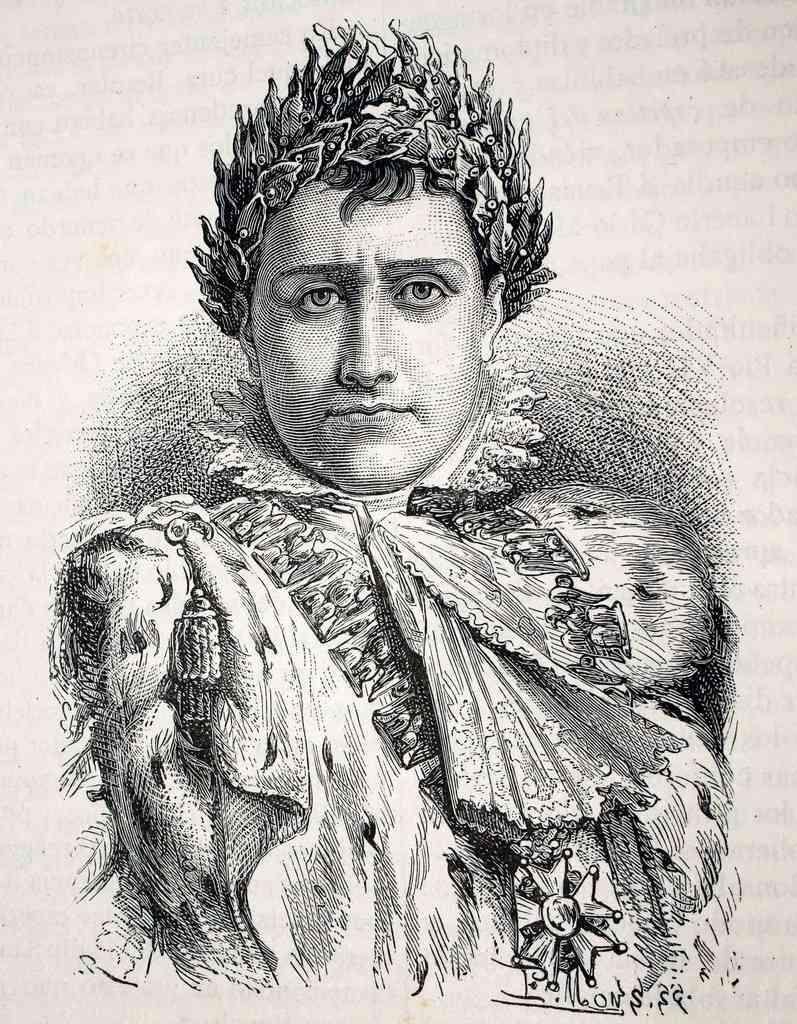What is depicted in the image? There is a drawing of a person in the image. Can you describe the person in the drawing? The person in the drawing is wearing a crown. What type of cloth is used to make the crown in the image? There is no information about the material used to make the crown in the image. 